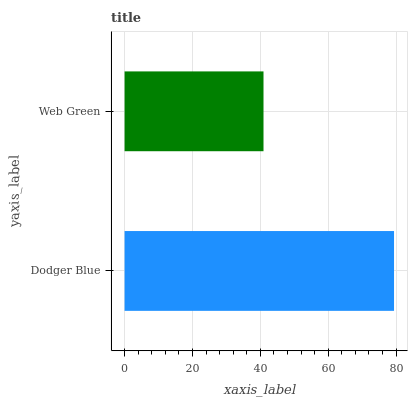Is Web Green the minimum?
Answer yes or no. Yes. Is Dodger Blue the maximum?
Answer yes or no. Yes. Is Web Green the maximum?
Answer yes or no. No. Is Dodger Blue greater than Web Green?
Answer yes or no. Yes. Is Web Green less than Dodger Blue?
Answer yes or no. Yes. Is Web Green greater than Dodger Blue?
Answer yes or no. No. Is Dodger Blue less than Web Green?
Answer yes or no. No. Is Dodger Blue the high median?
Answer yes or no. Yes. Is Web Green the low median?
Answer yes or no. Yes. Is Web Green the high median?
Answer yes or no. No. Is Dodger Blue the low median?
Answer yes or no. No. 